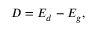Convert formula to latex. <formula><loc_0><loc_0><loc_500><loc_500>D = E _ { d } - E _ { g } ,</formula> 